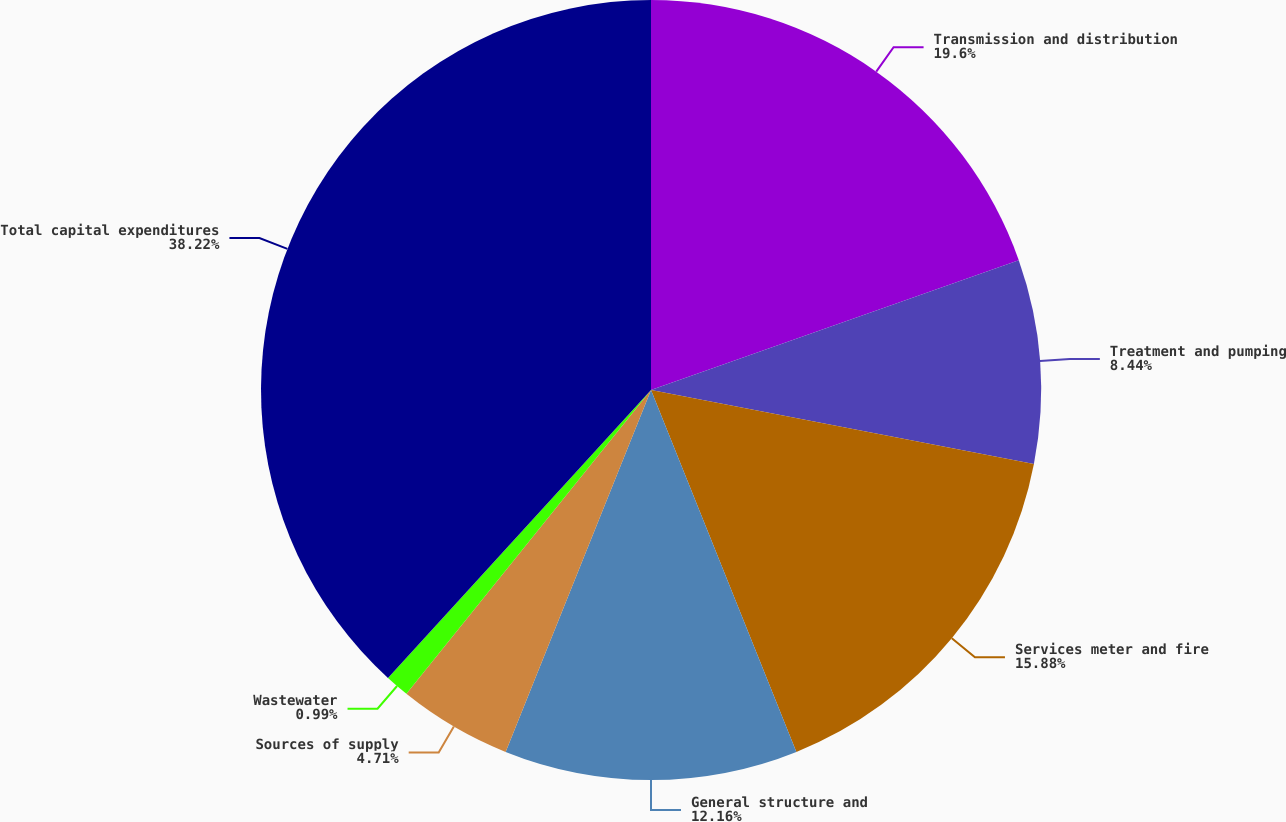Convert chart. <chart><loc_0><loc_0><loc_500><loc_500><pie_chart><fcel>Transmission and distribution<fcel>Treatment and pumping<fcel>Services meter and fire<fcel>General structure and<fcel>Sources of supply<fcel>Wastewater<fcel>Total capital expenditures<nl><fcel>19.6%<fcel>8.44%<fcel>15.88%<fcel>12.16%<fcel>4.71%<fcel>0.99%<fcel>38.22%<nl></chart> 